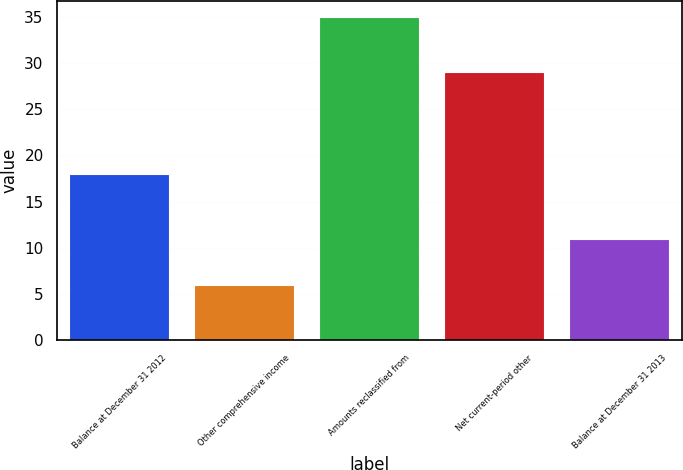Convert chart to OTSL. <chart><loc_0><loc_0><loc_500><loc_500><bar_chart><fcel>Balance at December 31 2012<fcel>Other comprehensive income<fcel>Amounts reclassified from<fcel>Net current-period other<fcel>Balance at December 31 2013<nl><fcel>18<fcel>6<fcel>35<fcel>29<fcel>11<nl></chart> 